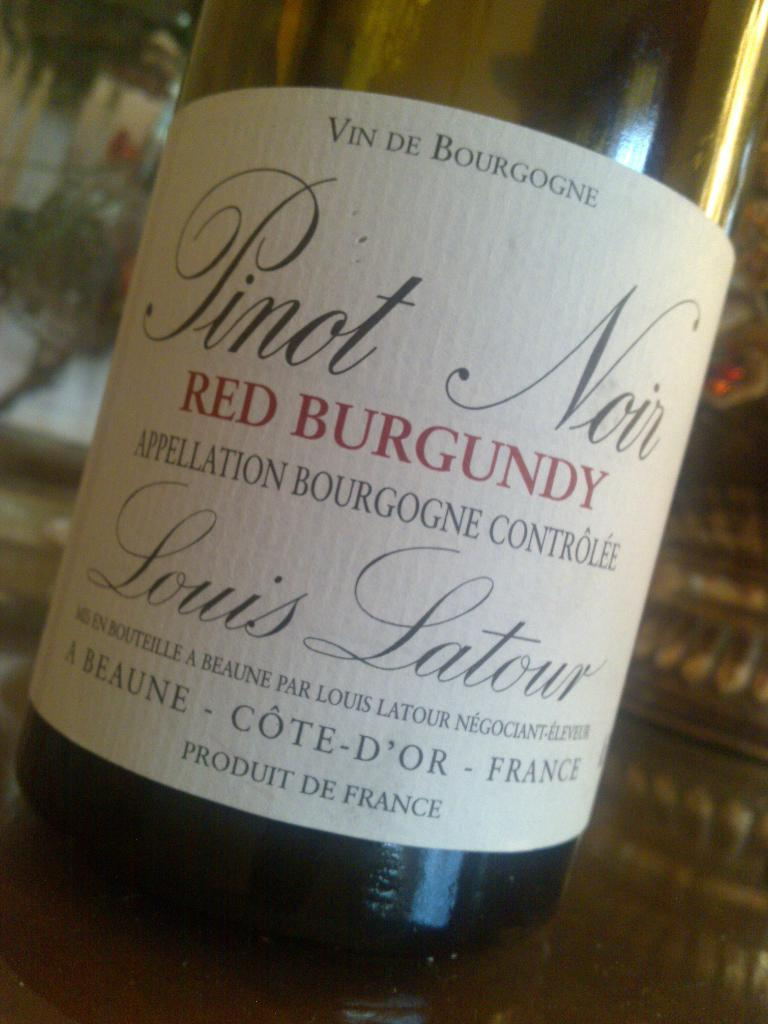<image>
Create a compact narrative representing the image presented. the word Burgundy is on a wine bottle 